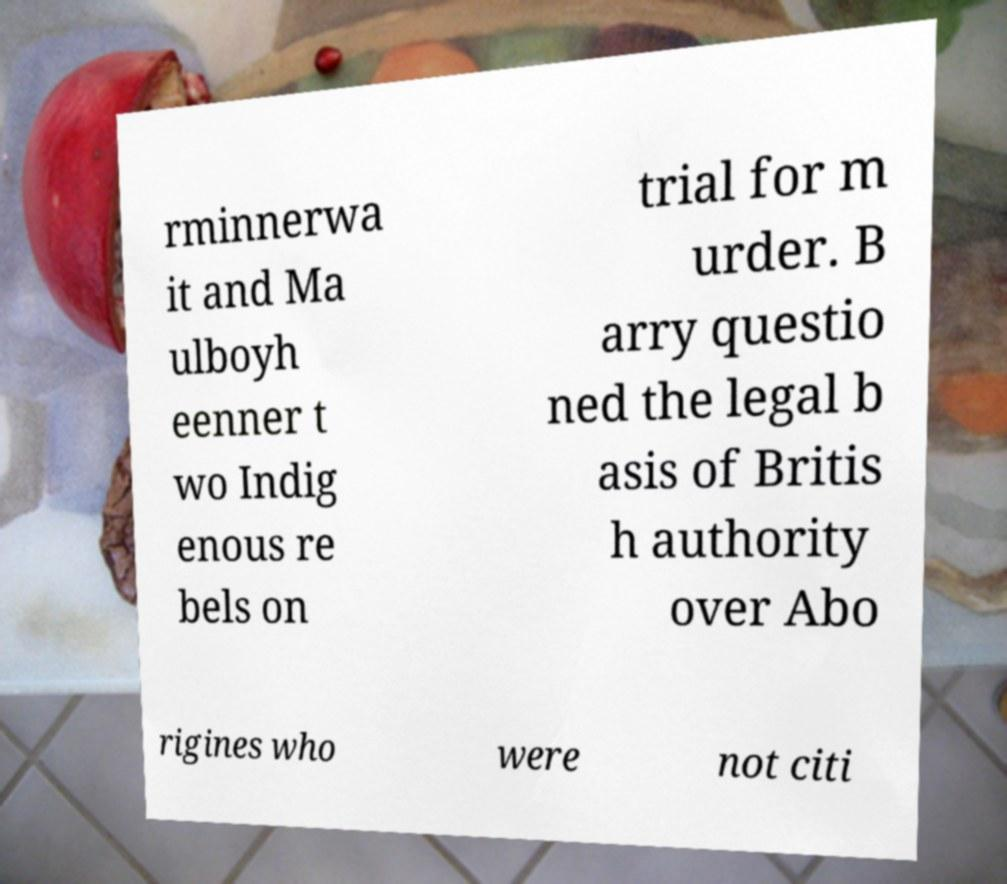Can you read and provide the text displayed in the image?This photo seems to have some interesting text. Can you extract and type it out for me? rminnerwa it and Ma ulboyh eenner t wo Indig enous re bels on trial for m urder. B arry questio ned the legal b asis of Britis h authority over Abo rigines who were not citi 